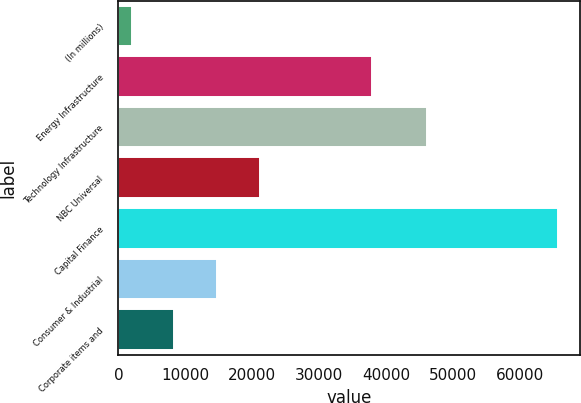<chart> <loc_0><loc_0><loc_500><loc_500><bar_chart><fcel>(In millions)<fcel>Energy Infrastructure<fcel>Technology Infrastructure<fcel>NBC Universal<fcel>Capital Finance<fcel>Consumer & Industrial<fcel>Corporate items and<nl><fcel>2008<fcel>37907<fcel>46043<fcel>21108.1<fcel>65675<fcel>14741.4<fcel>8374.7<nl></chart> 